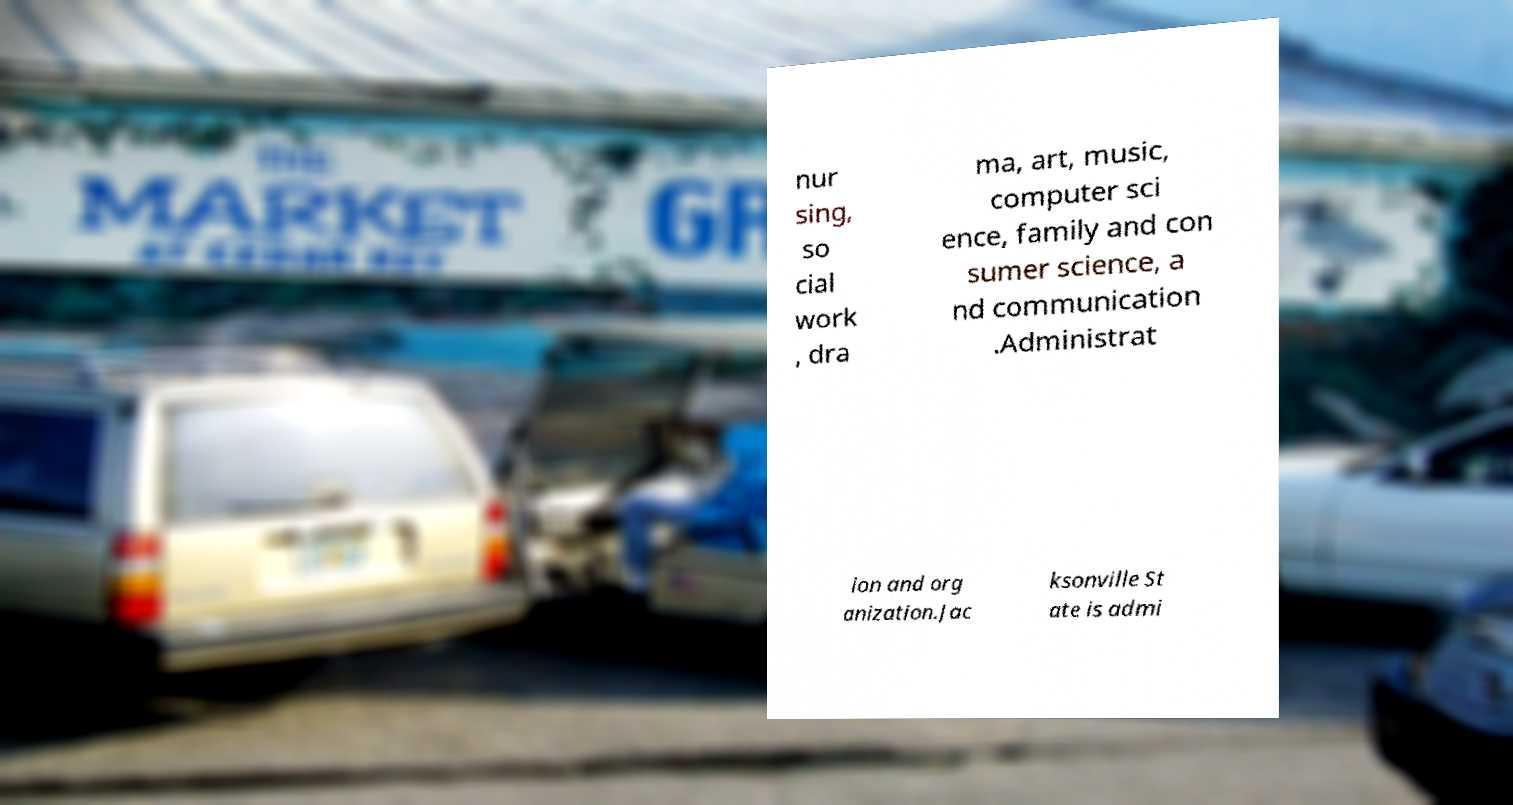What messages or text are displayed in this image? I need them in a readable, typed format. nur sing, so cial work , dra ma, art, music, computer sci ence, family and con sumer science, a nd communication .Administrat ion and org anization.Jac ksonville St ate is admi 